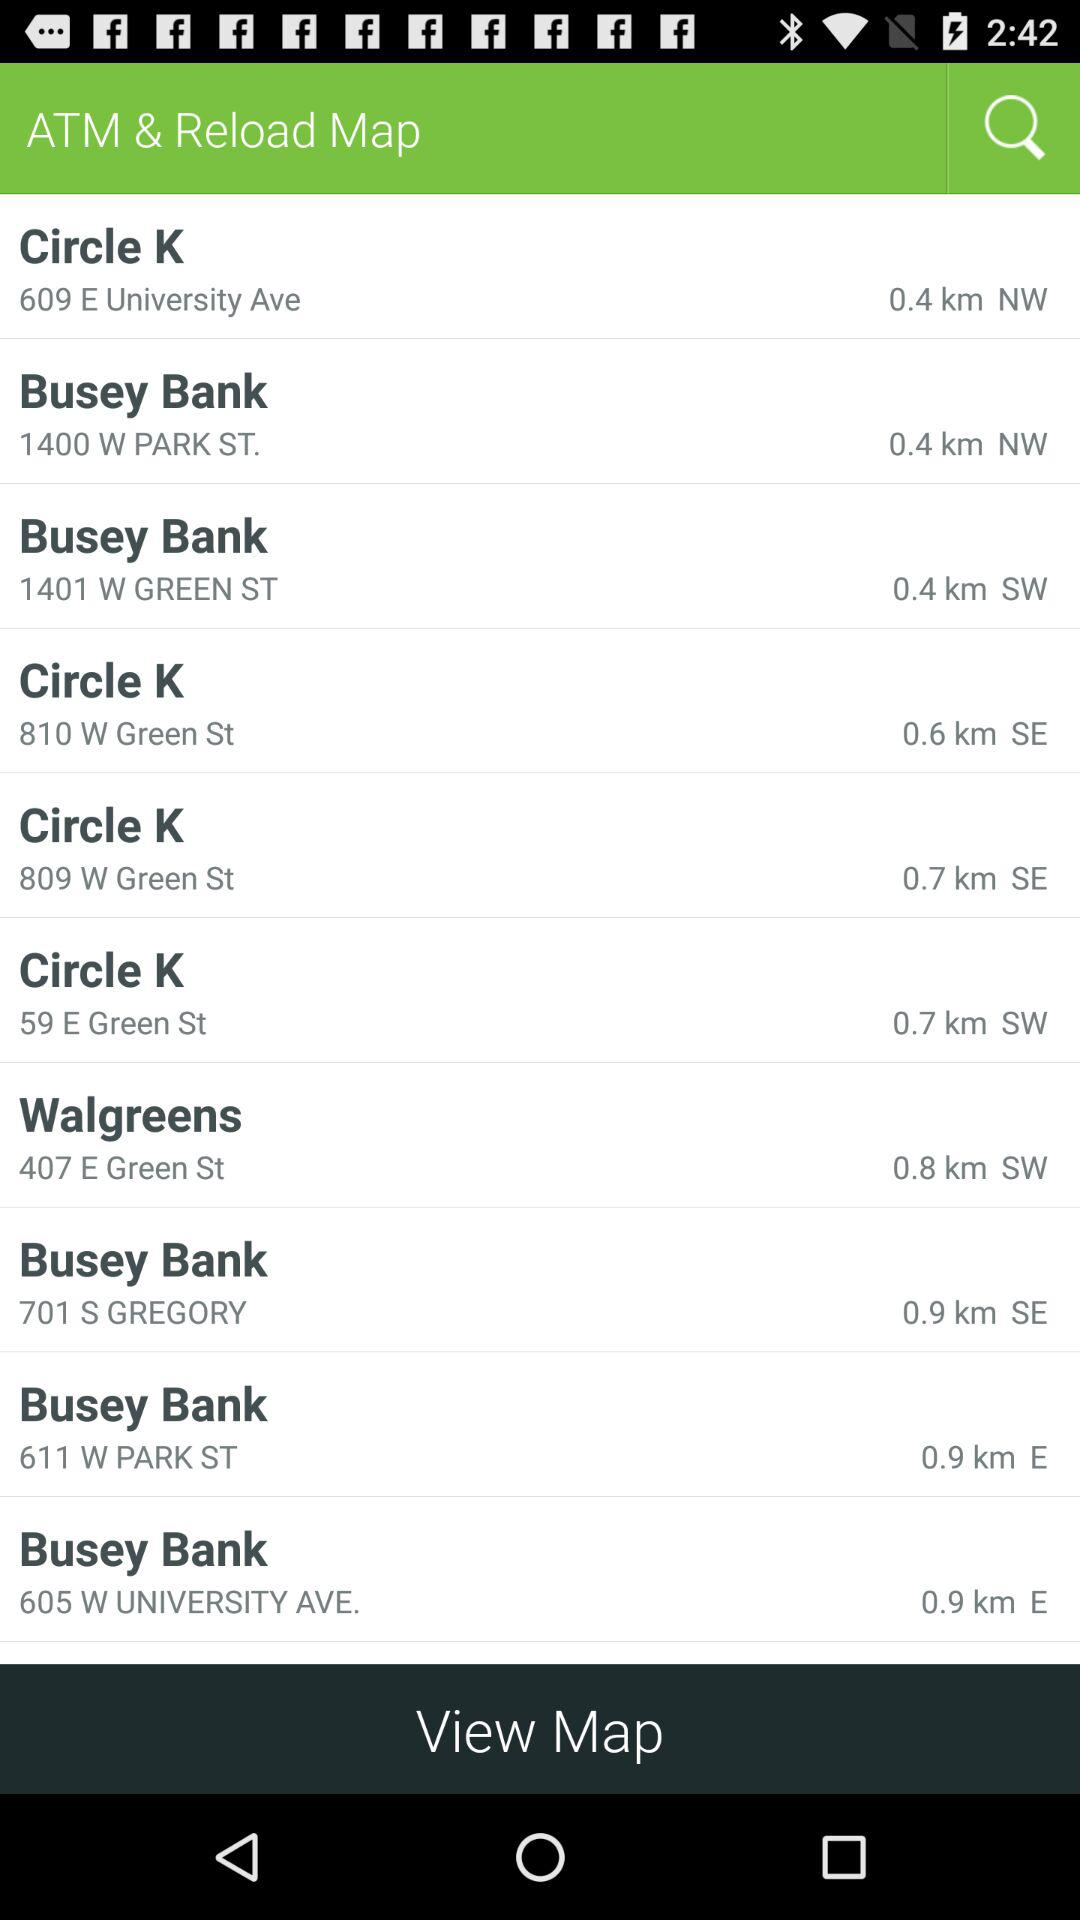Which ATM is in NW? The ATMs are "Circle K" and "Busey Bank". 